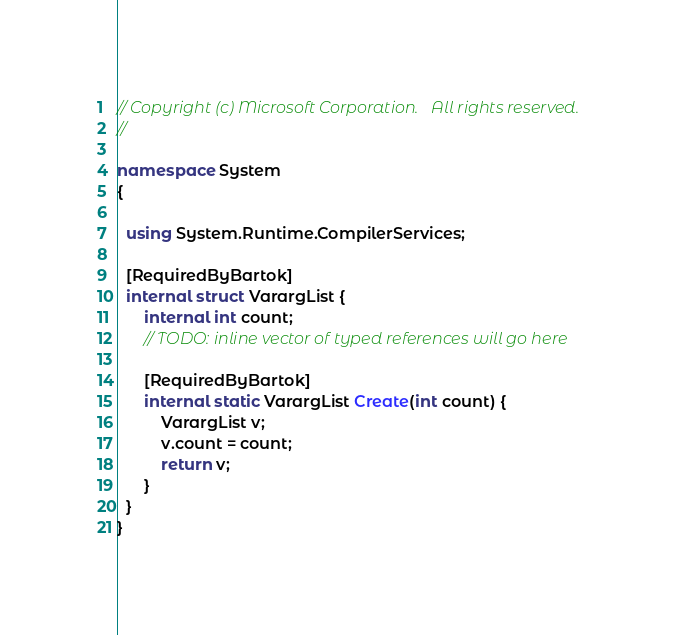Convert code to text. <code><loc_0><loc_0><loc_500><loc_500><_C#_>// Copyright (c) Microsoft Corporation.   All rights reserved.
//

namespace System
{

  using System.Runtime.CompilerServices;

  [RequiredByBartok]
  internal struct VarargList {
      internal int count;
      // TODO: inline vector of typed references will go here

      [RequiredByBartok]
      internal static VarargList Create(int count) {
          VarargList v;
          v.count = count;
          return v;
      }
  }
}
</code> 